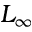Convert formula to latex. <formula><loc_0><loc_0><loc_500><loc_500>L _ { \infty }</formula> 